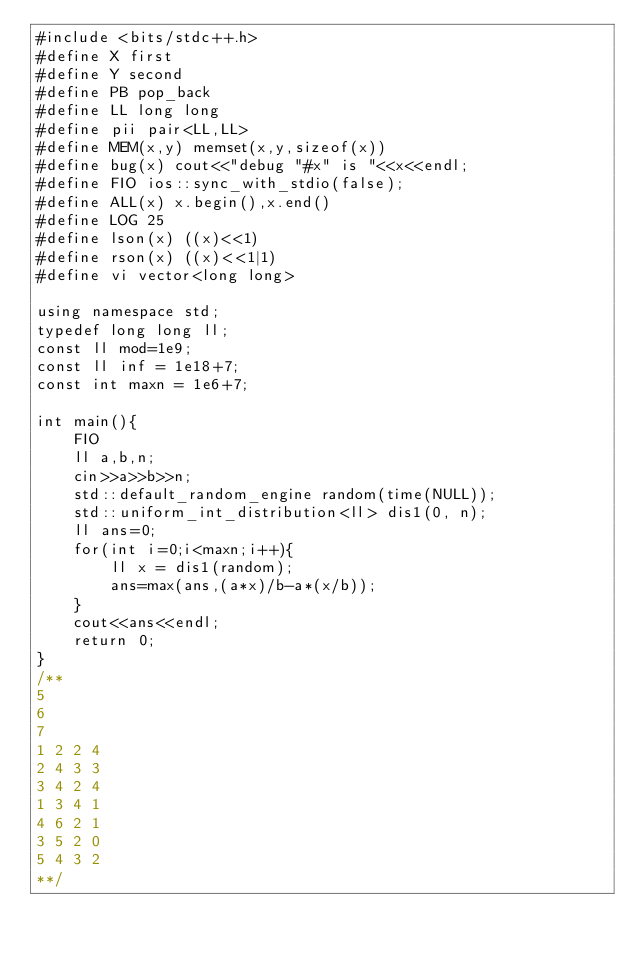<code> <loc_0><loc_0><loc_500><loc_500><_C++_>#include <bits/stdc++.h>
#define X first
#define Y second
#define PB pop_back
#define LL long long
#define pii pair<LL,LL>
#define MEM(x,y) memset(x,y,sizeof(x))
#define bug(x) cout<<"debug "#x" is "<<x<<endl;
#define FIO ios::sync_with_stdio(false);
#define ALL(x) x.begin(),x.end()
#define LOG 25
#define lson(x) ((x)<<1)
#define rson(x) ((x)<<1|1)
#define vi vector<long long>

using namespace std;
typedef long long ll;
const ll mod=1e9;
const ll inf = 1e18+7;
const int maxn = 1e6+7;

int main(){
    FIO
    ll a,b,n;
    cin>>a>>b>>n;
    std::default_random_engine random(time(NULL));
    std::uniform_int_distribution<ll> dis1(0, n);
    ll ans=0;
    for(int i=0;i<maxn;i++){
        ll x = dis1(random);
        ans=max(ans,(a*x)/b-a*(x/b));
    }
    cout<<ans<<endl;
    return 0;
}
/**
5
6
7
1 2 2 4
2 4 3 3
3 4 2 4
1 3 4 1
4 6 2 1
3 5 2 0
5 4 3 2
**/
</code> 